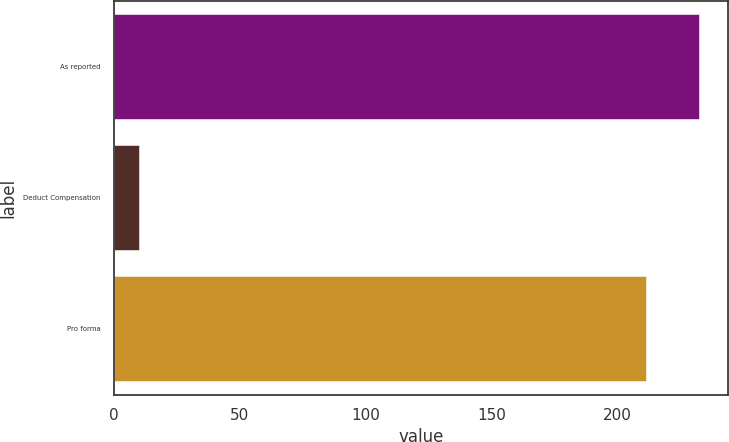Convert chart. <chart><loc_0><loc_0><loc_500><loc_500><bar_chart><fcel>As reported<fcel>Deduct Compensation<fcel>Pro forma<nl><fcel>232.21<fcel>9.9<fcel>211.1<nl></chart> 